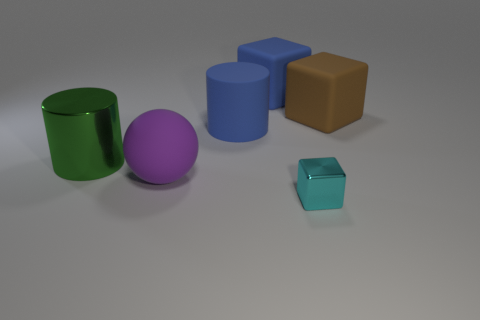Add 2 big green metallic things. How many objects exist? 8 Subtract all cylinders. How many objects are left? 4 Add 3 big matte things. How many big matte things are left? 7 Add 2 shiny cylinders. How many shiny cylinders exist? 3 Subtract 1 purple balls. How many objects are left? 5 Subtract all gray metallic things. Subtract all green metal objects. How many objects are left? 5 